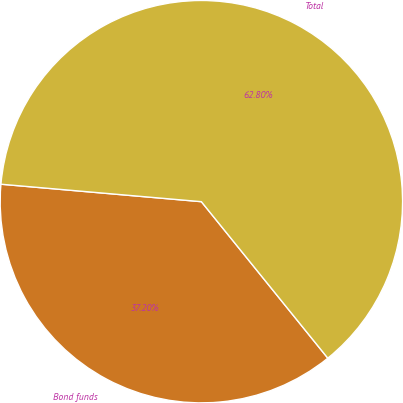Convert chart. <chart><loc_0><loc_0><loc_500><loc_500><pie_chart><fcel>Bond funds<fcel>Total<nl><fcel>37.2%<fcel>62.8%<nl></chart> 